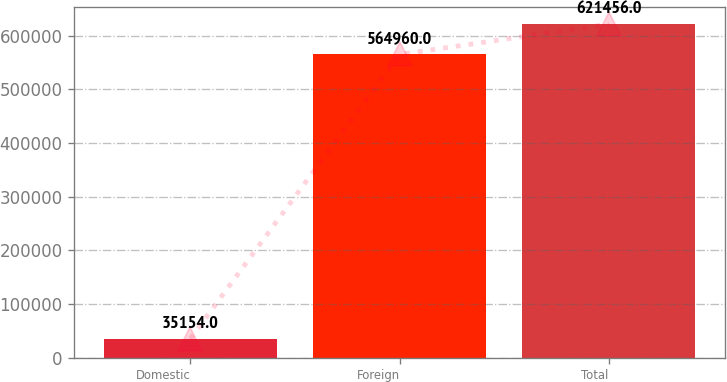Convert chart to OTSL. <chart><loc_0><loc_0><loc_500><loc_500><bar_chart><fcel>Domestic<fcel>Foreign<fcel>Total<nl><fcel>35154<fcel>564960<fcel>621456<nl></chart> 